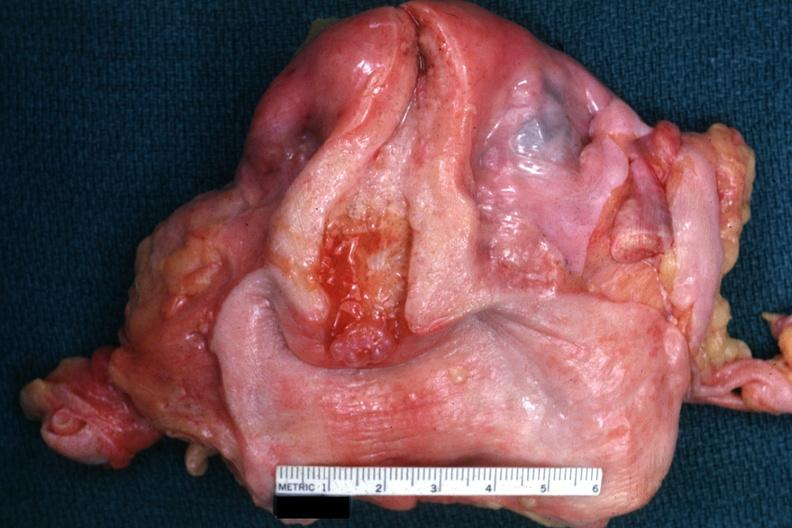does this image show excellent example with opened uterus and cervix and vagina?
Answer the question using a single word or phrase. Yes 